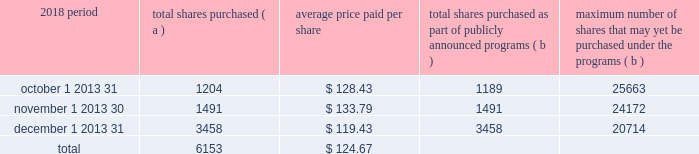The pnc financial services group , inc .
2013 form 10-k 29 part ii item 5 2013 market for registrant 2019s common equity , related stockholder matters and issuer purchases of equity securities ( a ) ( 1 ) our common stock is listed on the new york stock exchange and is traded under the symbol 201cpnc . 201d at the close of business on february 15 , 2019 , there were 53986 common shareholders of record .
Holders of pnc common stock are entitled to receive dividends when declared by our board of directors out of funds legally available for this purpose .
Our board of directors may not pay or set apart dividends on the common stock until dividends for all past dividend periods on any series of outstanding preferred stock and certain outstanding capital securities issued by the parent company have been paid or declared and set apart for payment .
The board of directors presently intends to continue the policy of paying quarterly cash dividends .
The amount of any future dividends will depend on economic and market conditions , our financial condition and operating results , and other factors , including contractual restrictions and applicable government regulations and policies ( such as those relating to the ability of bank and non-bank subsidiaries to pay dividends to the parent company and regulatory capital limitations ) .
The amount of our dividend is also currently subject to the results of the supervisory assessment of capital adequacy and capital planning processes undertaken by the federal reserve and our primary bank regulators as part of the comprehensive capital analysis and review ( ccar ) process as described in the supervision and regulation section in item 1 of this report .
The federal reserve has the power to prohibit us from paying dividends without its approval .
For further information concerning dividend restrictions and other factors that could limit our ability to pay dividends , as well as restrictions on loans , dividends or advances from bank subsidiaries to the parent company , see the supervision and regulation section in item 1 , item 1a risk factors , the liquidity and capital management portion of the risk management section in item 7 , and note 10 borrowed funds , note 15 equity and note 18 regulatory matters in the notes to consolidated financial statements in item 8 of this report , which we include here by reference .
We include here by reference the information regarding our compensation plans under which pnc equity securities are authorized for issuance as of december 31 , 2018 in the table ( with introductory paragraph and notes ) in item 12 of this report .
Our stock transfer agent and registrar is : computershare trust company , n.a .
250 royall street canton , ma 02021 800-982-7652 www.computershare.com/pnc registered shareholders may contact computershare regarding dividends and other shareholder services .
We include here by reference the information that appears under the common stock performance graph caption at the end of this item 5 .
( a ) ( 2 ) none .
( b ) not applicable .
( c ) details of our repurchases of pnc common stock during the fourth quarter of 2018 are included in the table : in thousands , except per share data 2018 period total shares purchased ( a ) average price paid per share total shares purchased as part of publicly announced programs ( b ) maximum number of shares that may yet be purchased under the programs ( b ) .
( a ) includes pnc common stock purchased in connection with our various employee benefit plans generally related to forfeitures of unvested restricted stock awards and shares used to cover employee payroll tax withholding requirements .
Note 11 employee benefit plans and note 12 stock based compensation plans in the notes to consolidated financial statements in item 8 of this report include additional information regarding our employee benefit and equity compensation plans that use pnc common stock .
( b ) on march 11 , 2015 , we announced that our board of directors approved a stock repurchase program authorization in the amount of 100 million shares of pnc common stock , effective april 1 , 2015 .
Repurchases are made in open market or privately negotiated transactions and the timing and exact amount of common stock repurchases will depend on a number of factors including , among others , market and general economic conditions , regulatory capital considerations , alternative uses of capital , the potential impact on our credit ratings , and contractual and regulatory limitations , including the results of the supervisory assessment of capital adequacy and capital planning processes undertaken by the federal reserve as part of the ccar process .
In june 2018 , we announced share repurchase programs of up to $ 2.0 billion for the four quarter period beginning with the third quarter of 2018 , including repurchases of up to $ 300 million related to stock issuances under employee benefit plans , in accordance with pnc's 2018 capital plan .
In november 2018 , we announced an increase to these previously announced programs in the amount of up to $ 900 million in additional common share repurchases .
The aggregate repurchase price of shares repurchased during the fourth quarter of 2018 was $ .8 billion .
See the liquidity and capital management portion of the risk management section in item 7 of this report for more information on the authorized share repurchase programs for the period july 1 , 2018 through june 30 , 2019 .
Http://www.computershare.com/pnc .
What total percentage of total shares were purchased in november and december? 
Computations: (((1491 + 3458) / 6153) * 100)
Answer: 80.43231. 